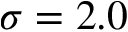Convert formula to latex. <formula><loc_0><loc_0><loc_500><loc_500>\sigma = 2 . 0</formula> 